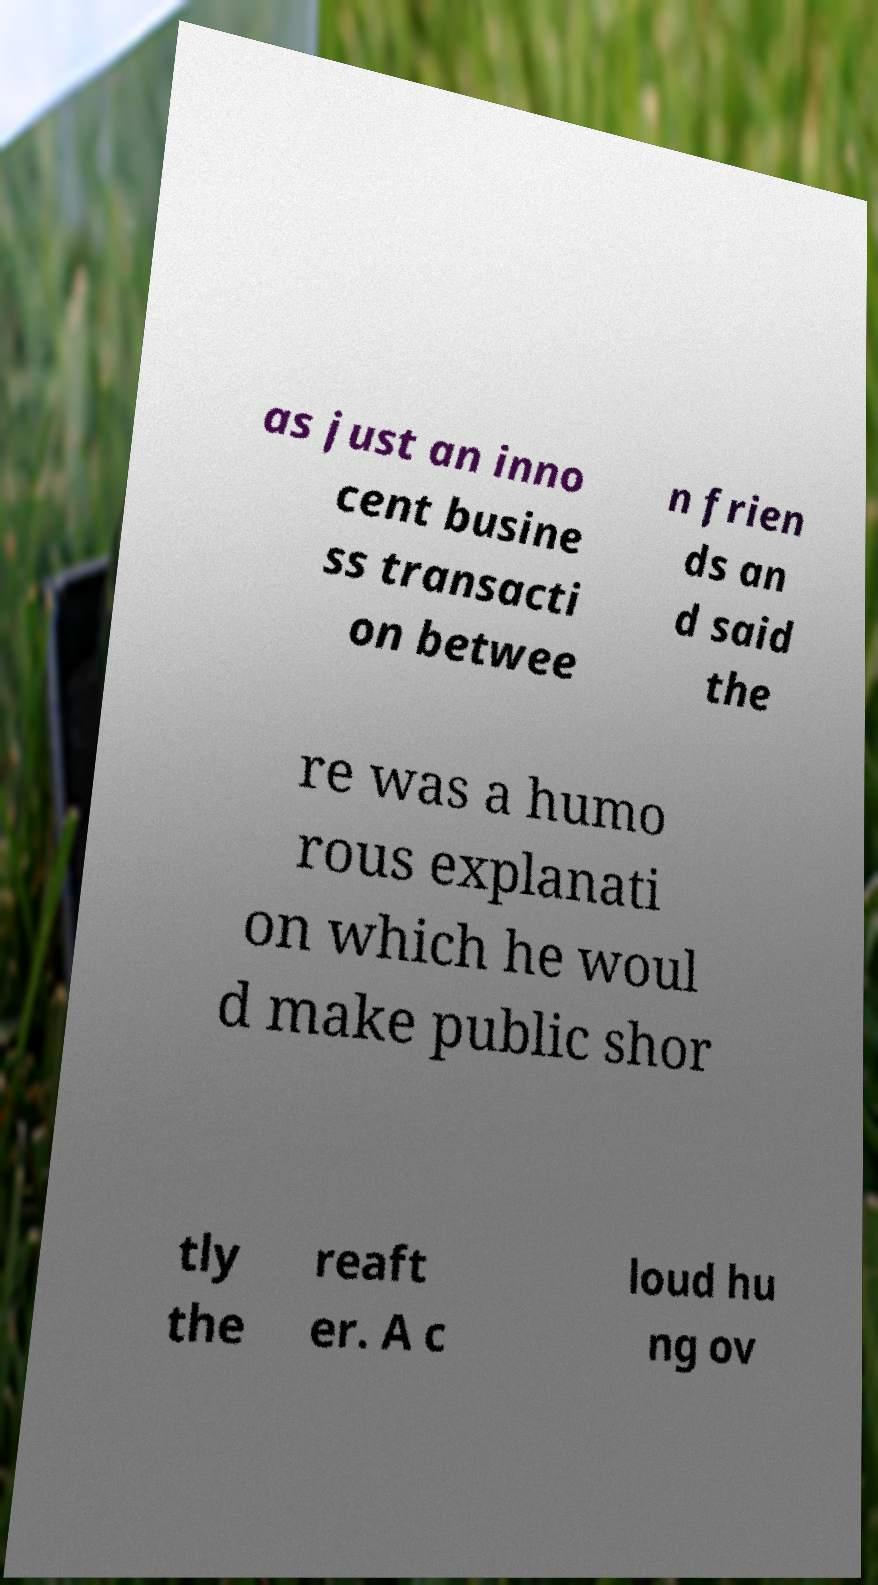For documentation purposes, I need the text within this image transcribed. Could you provide that? as just an inno cent busine ss transacti on betwee n frien ds an d said the re was a humo rous explanati on which he woul d make public shor tly the reaft er. A c loud hu ng ov 